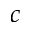<formula> <loc_0><loc_0><loc_500><loc_500>c</formula> 